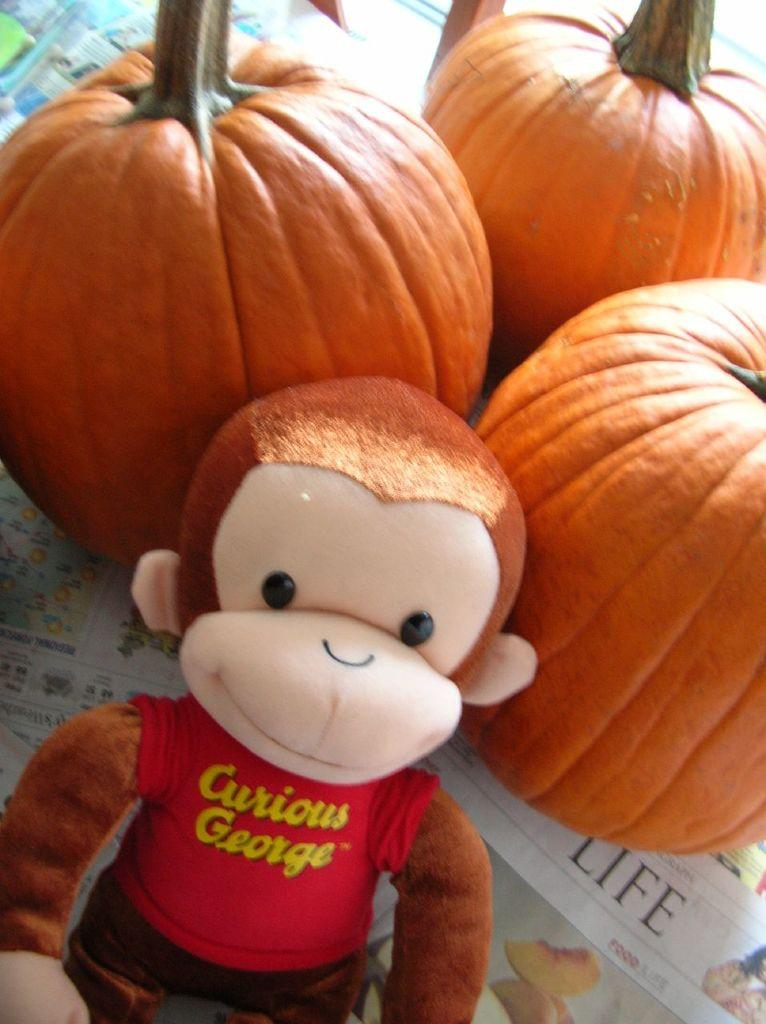How many pumpkins are visible in the image? There are three pumpkins in the image. What other object can be seen in the image besides the pumpkins? There is a toy in the image. What type of reading material is present in the image? Newspapers are present in the image. What type of eggs are being delivered by the truck in the image? There is no truck or eggs present in the image. How does the toy say good-bye to the pumpkins in the image? The image does not depict any interaction between the toy and the pumpkins, nor does it show the toy saying good-bye. 